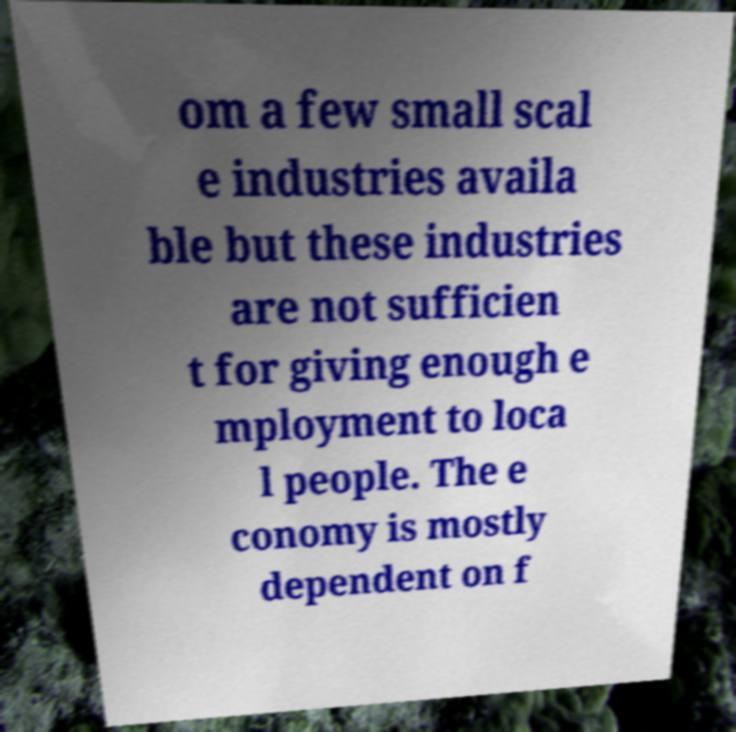Can you accurately transcribe the text from the provided image for me? om a few small scal e industries availa ble but these industries are not sufficien t for giving enough e mployment to loca l people. The e conomy is mostly dependent on f 